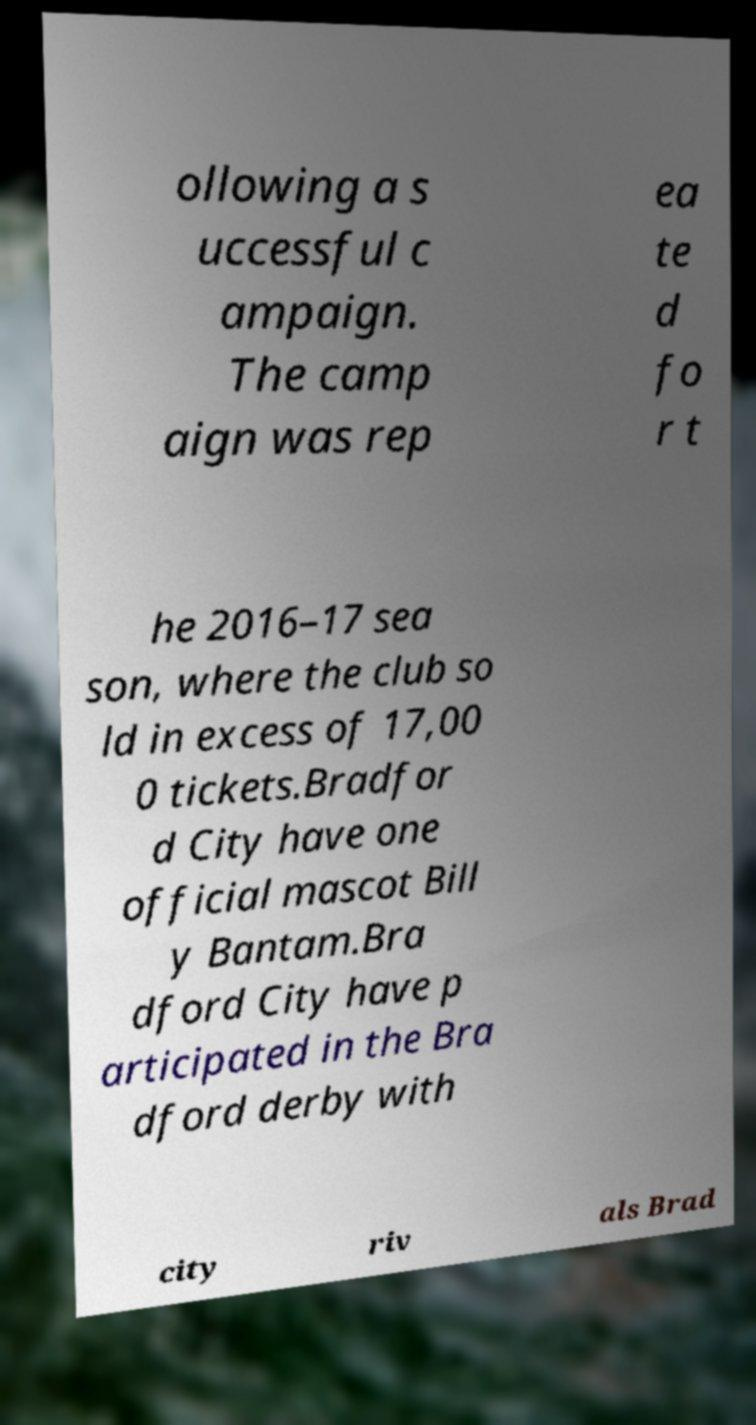There's text embedded in this image that I need extracted. Can you transcribe it verbatim? ollowing a s uccessful c ampaign. The camp aign was rep ea te d fo r t he 2016–17 sea son, where the club so ld in excess of 17,00 0 tickets.Bradfor d City have one official mascot Bill y Bantam.Bra dford City have p articipated in the Bra dford derby with city riv als Brad 